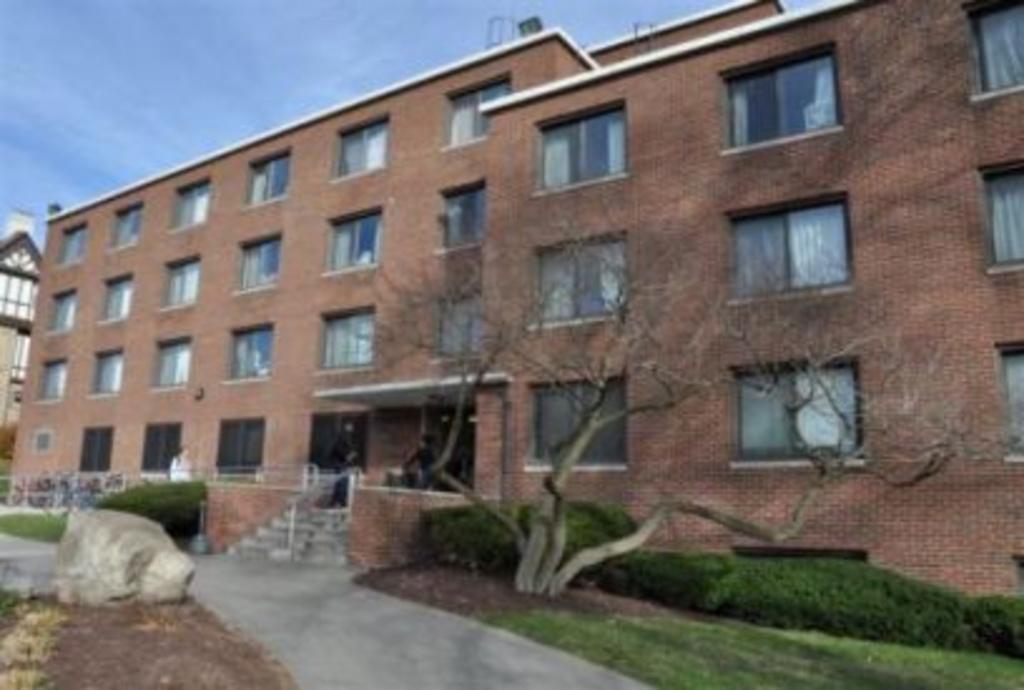Can you describe this image briefly? As we can see in the image there are buildings, trees, plants, grass, rock, stairs, windows and sky. 